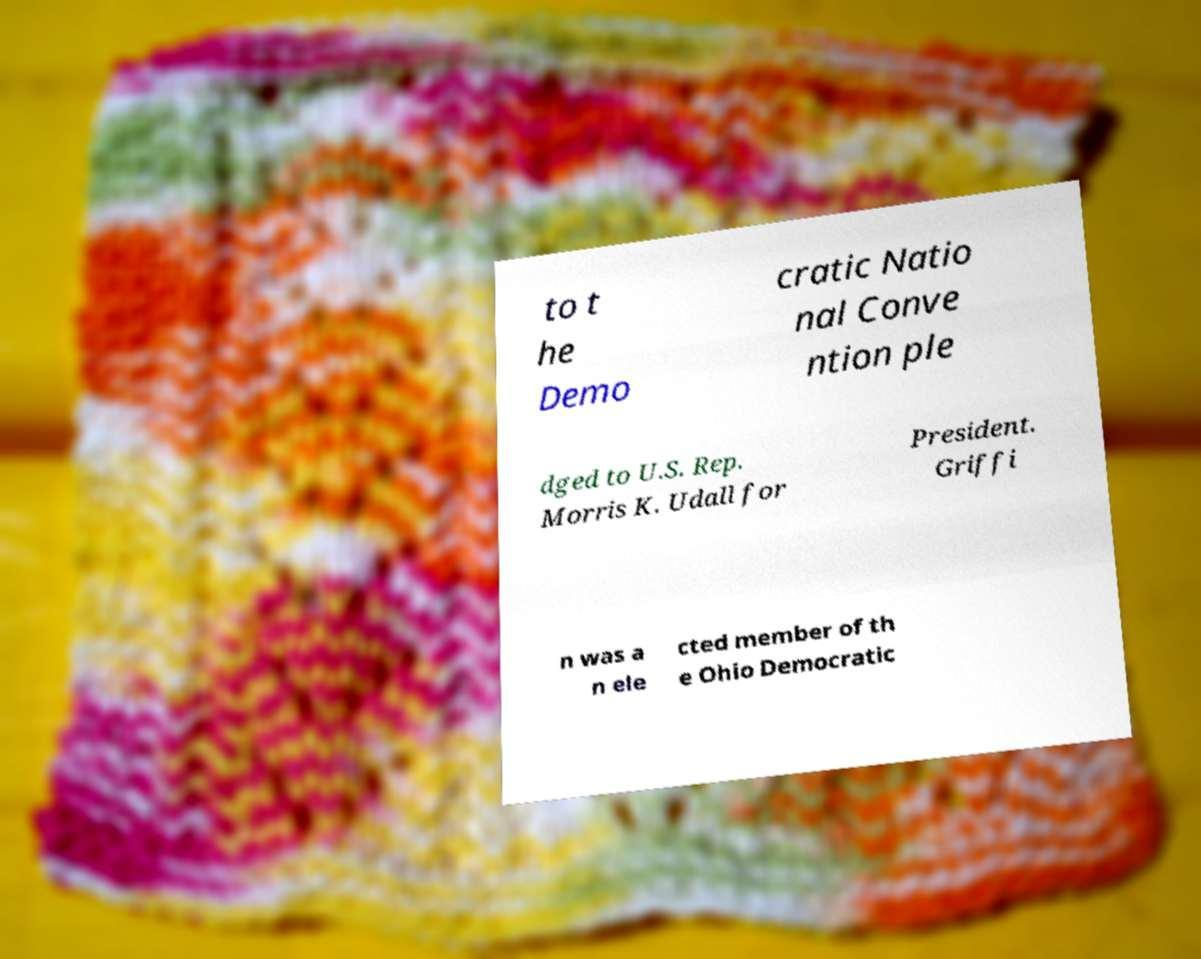What messages or text are displayed in this image? I need them in a readable, typed format. to t he Demo cratic Natio nal Conve ntion ple dged to U.S. Rep. Morris K. Udall for President. Griffi n was a n ele cted member of th e Ohio Democratic 